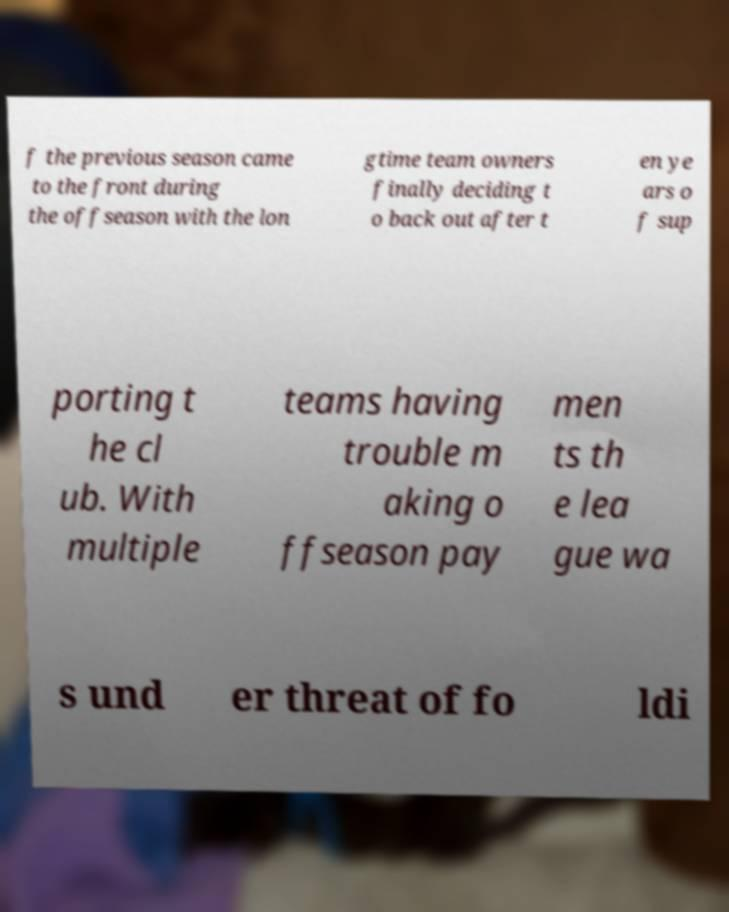Could you extract and type out the text from this image? f the previous season came to the front during the offseason with the lon gtime team owners finally deciding t o back out after t en ye ars o f sup porting t he cl ub. With multiple teams having trouble m aking o ffseason pay men ts th e lea gue wa s und er threat of fo ldi 